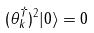Convert formula to latex. <formula><loc_0><loc_0><loc_500><loc_500>( \theta _ { k } ^ { \dagger } ) ^ { 2 } | 0 \rangle = 0</formula> 